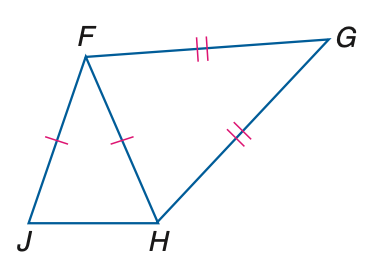Answer the mathemtical geometry problem and directly provide the correct option letter.
Question: In the figure, F J \cong F H and G F \cong G H. If m \angle G H J = 152 and m \angle G = 32, find m \angle J F H.
Choices: A: 12 B: 24 C: 32 D: 78 B 